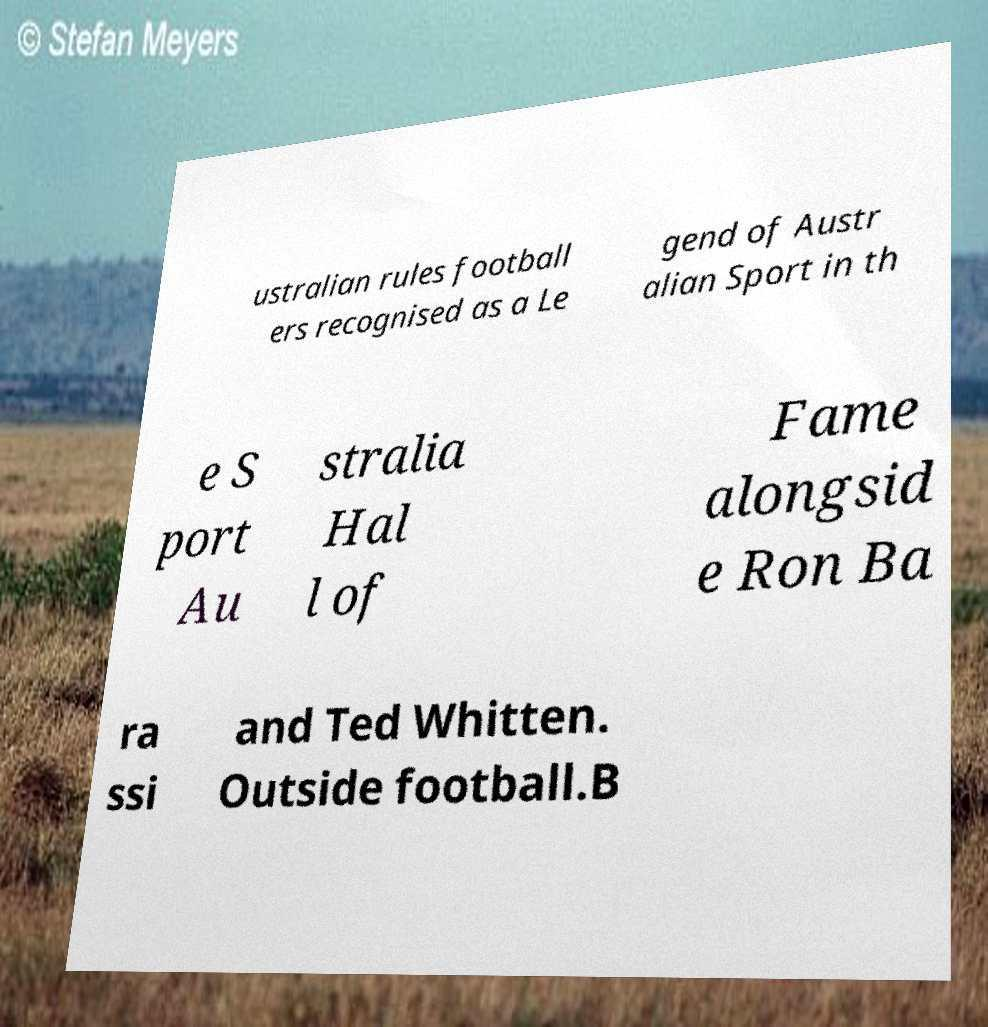I need the written content from this picture converted into text. Can you do that? ustralian rules football ers recognised as a Le gend of Austr alian Sport in th e S port Au stralia Hal l of Fame alongsid e Ron Ba ra ssi and Ted Whitten. Outside football.B 